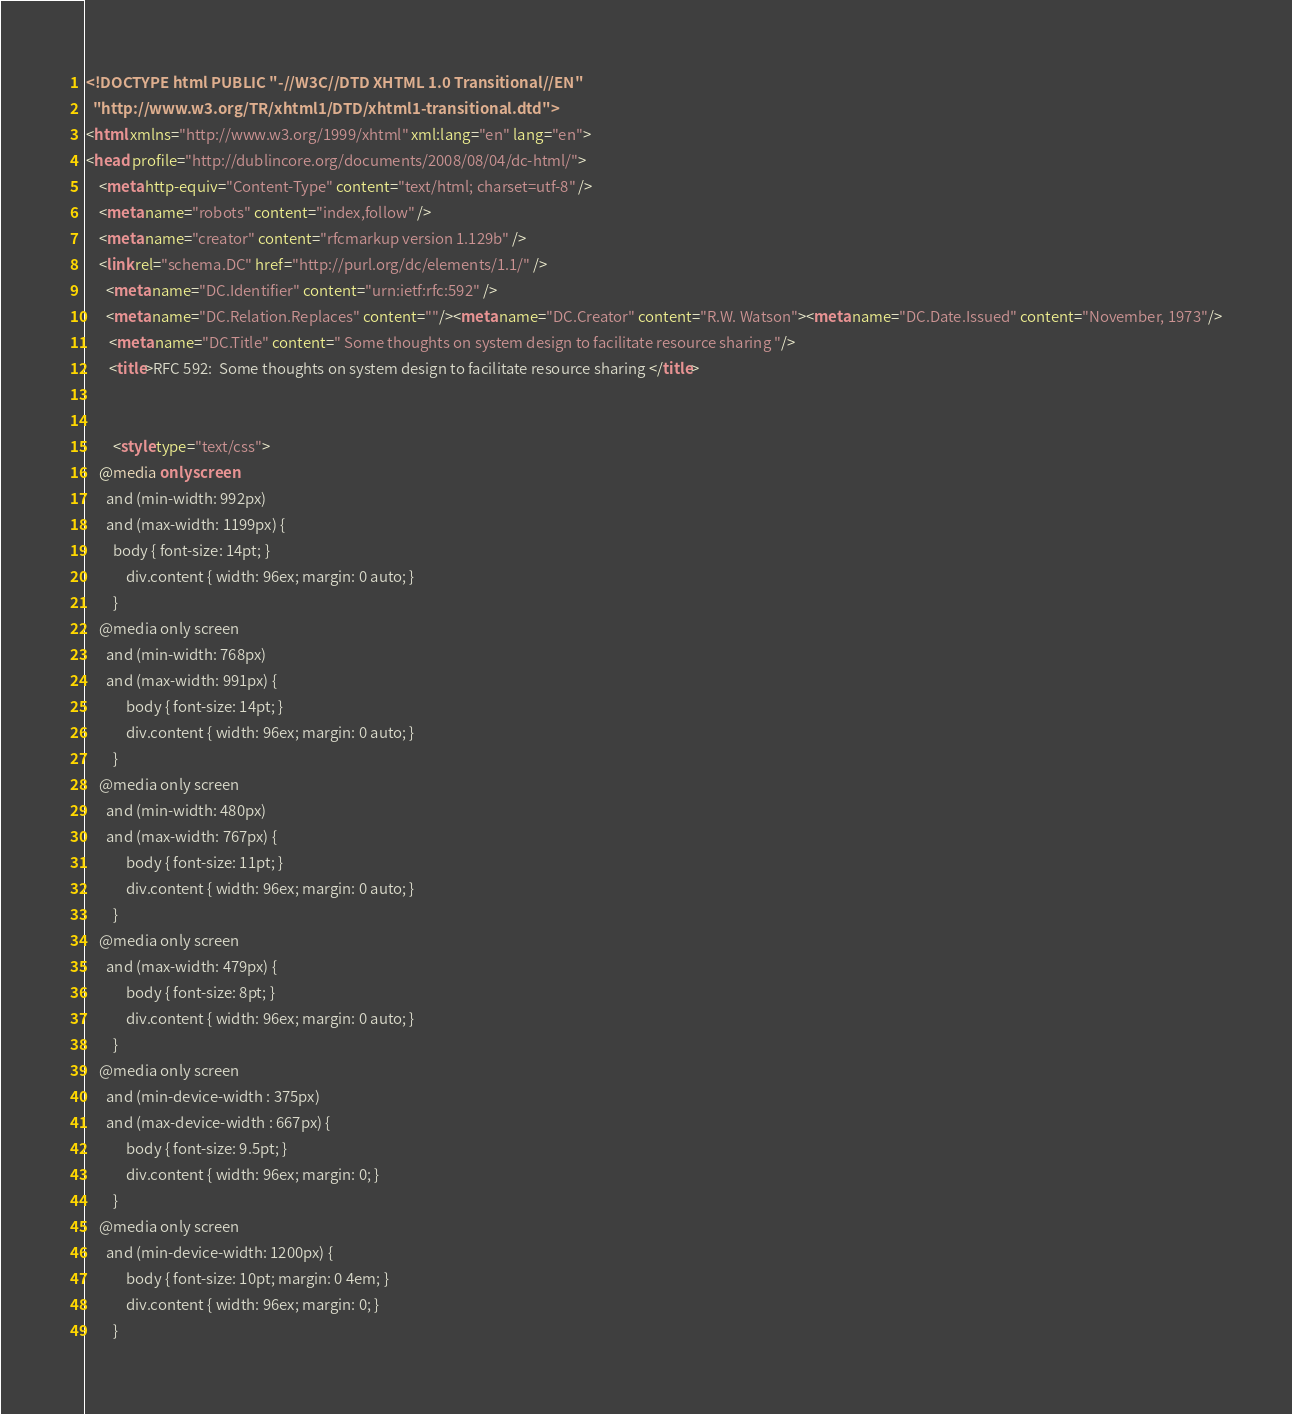Convert code to text. <code><loc_0><loc_0><loc_500><loc_500><_HTML_><!DOCTYPE html PUBLIC "-//W3C//DTD XHTML 1.0 Transitional//EN"
  "http://www.w3.org/TR/xhtml1/DTD/xhtml1-transitional.dtd">
<html xmlns="http://www.w3.org/1999/xhtml" xml:lang="en" lang="en">
<head profile="http://dublincore.org/documents/2008/08/04/dc-html/">
    <meta http-equiv="Content-Type" content="text/html; charset=utf-8" />
    <meta name="robots" content="index,follow" />
    <meta name="creator" content="rfcmarkup version 1.129b" />
    <link rel="schema.DC" href="http://purl.org/dc/elements/1.1/" />
      <meta name="DC.Identifier" content="urn:ietf:rfc:592" />
      <meta name="DC.Relation.Replaces" content=""/><meta name="DC.Creator" content="R.W. Watson"><meta name="DC.Date.Issued" content="November, 1973"/>
       <meta name="DC.Title" content=" Some thoughts on system design to facilitate resource sharing "/>
       <title>RFC 592:  Some thoughts on system design to facilitate resource sharing </title>    
        

        <style type="text/css">
	@media only screen 
	  and (min-width: 992px)
	  and (max-width: 1199px) {
	    body { font-size: 14pt; }
            div.content { width: 96ex; margin: 0 auto; }
        }
	@media only screen 
	  and (min-width: 768px)
	  and (max-width: 991px) {
            body { font-size: 14pt; }
            div.content { width: 96ex; margin: 0 auto; }
        }
	@media only screen 
	  and (min-width: 480px)
	  and (max-width: 767px) {
            body { font-size: 11pt; }
            div.content { width: 96ex; margin: 0 auto; }
        }
	@media only screen 
	  and (max-width: 479px) {
            body { font-size: 8pt; }
            div.content { width: 96ex; margin: 0 auto; }
        }
	@media only screen 
	  and (min-device-width : 375px) 
	  and (max-device-width : 667px) {
            body { font-size: 9.5pt; }
            div.content { width: 96ex; margin: 0; }
        }
	@media only screen 
	  and (min-device-width: 1200px) {
            body { font-size: 10pt; margin: 0 4em; }
            div.content { width: 96ex; margin: 0; }
        }</code> 